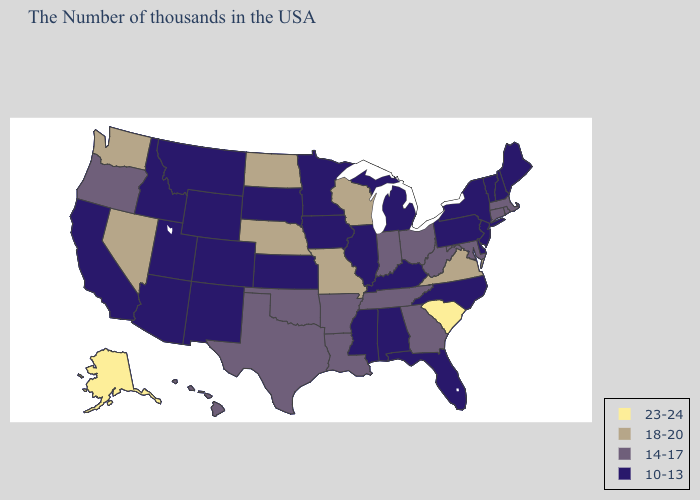Name the states that have a value in the range 18-20?
Give a very brief answer. Virginia, Wisconsin, Missouri, Nebraska, North Dakota, Nevada, Washington. What is the highest value in the South ?
Keep it brief. 23-24. Is the legend a continuous bar?
Short answer required. No. What is the lowest value in states that border Kentucky?
Write a very short answer. 10-13. Does North Dakota have the highest value in the MidWest?
Quick response, please. Yes. What is the highest value in the West ?
Keep it brief. 23-24. Which states have the highest value in the USA?
Be succinct. South Carolina, Alaska. Name the states that have a value in the range 23-24?
Quick response, please. South Carolina, Alaska. Among the states that border Texas , does New Mexico have the highest value?
Give a very brief answer. No. Does Nebraska have the lowest value in the USA?
Answer briefly. No. Does the first symbol in the legend represent the smallest category?
Answer briefly. No. Among the states that border New Hampshire , does Vermont have the highest value?
Concise answer only. No. What is the value of Nevada?
Give a very brief answer. 18-20. Name the states that have a value in the range 10-13?
Be succinct. Maine, New Hampshire, Vermont, New York, New Jersey, Delaware, Pennsylvania, North Carolina, Florida, Michigan, Kentucky, Alabama, Illinois, Mississippi, Minnesota, Iowa, Kansas, South Dakota, Wyoming, Colorado, New Mexico, Utah, Montana, Arizona, Idaho, California. Does Iowa have the same value as California?
Write a very short answer. Yes. 